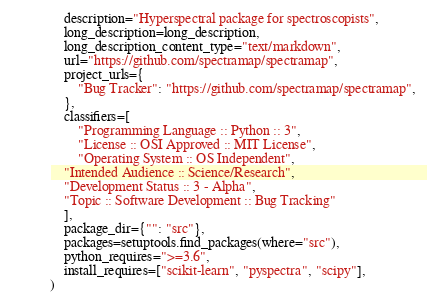Convert code to text. <code><loc_0><loc_0><loc_500><loc_500><_Python_>    description="Hyperspectral package for spectroscopists",
    long_description=long_description,
    long_description_content_type="text/markdown",
    url="https://github.com/spectramap/spectramap",
    project_urls={
        "Bug Tracker": "https://github.com/spectramap/spectramap",
    },
    classifiers=[
        "Programming Language :: Python :: 3",
        "License :: OSI Approved :: MIT License",
        "Operating System :: OS Independent",
	"Intended Audience :: Science/Research",
	"Development Status :: 3 - Alpha",
	"Topic :: Software Development :: Bug Tracking"
    ],
    package_dir={"": "src"},
    packages=setuptools.find_packages(where="src"),
    python_requires=">=3.6",
    install_requires=["scikit-learn", "pyspectra", "scipy"],
)</code> 